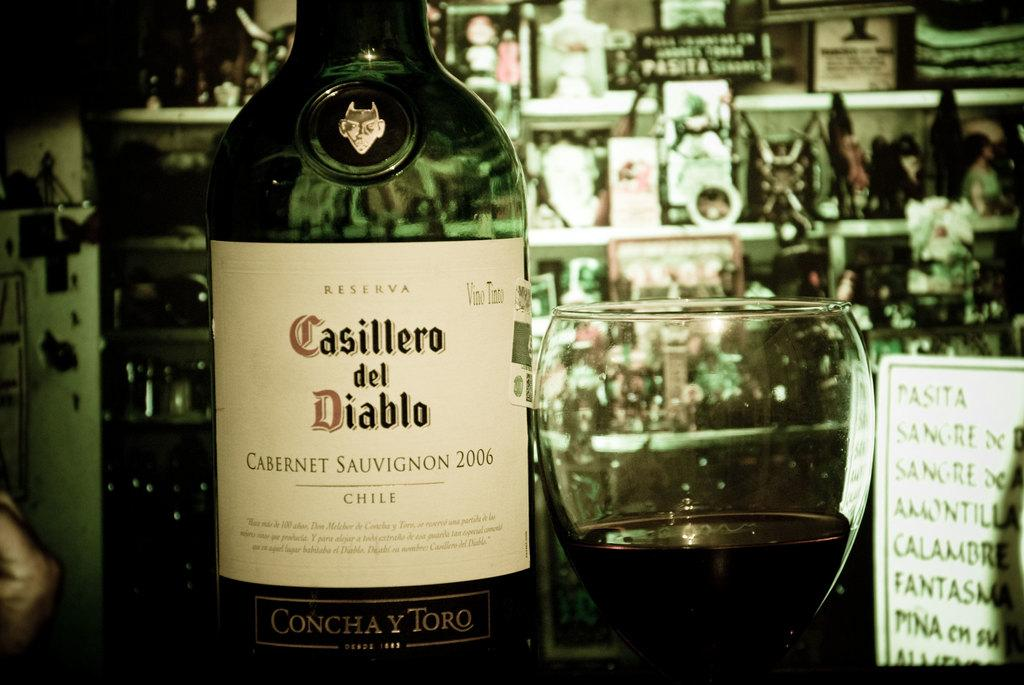Provide a one-sentence caption for the provided image. A bottle of red wine from Chile sits next to a half full wine glass. 